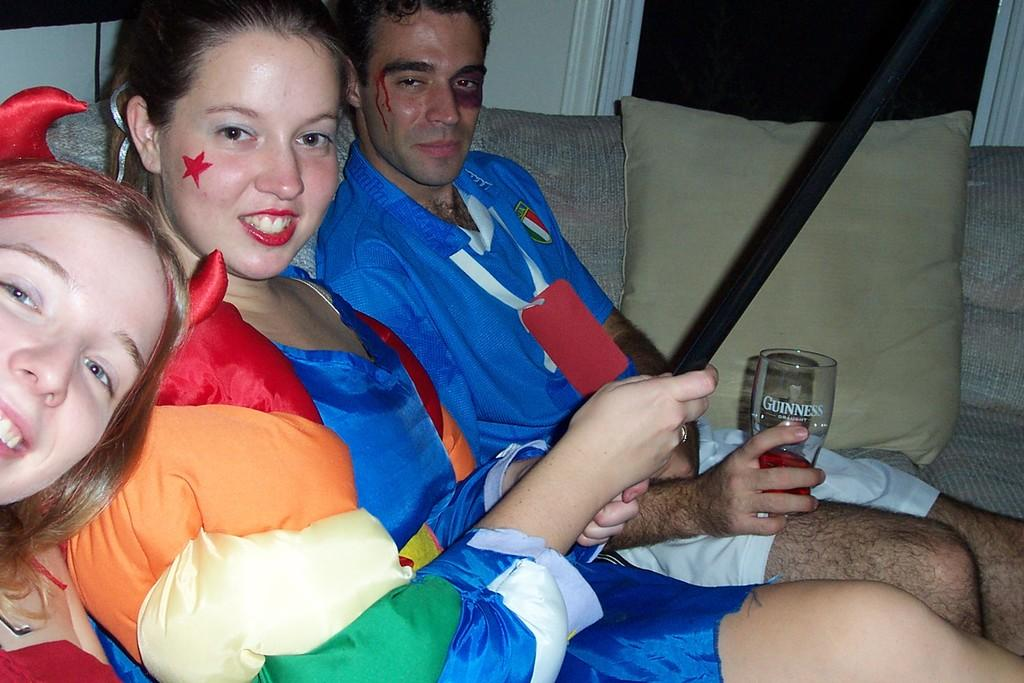<image>
Relay a brief, clear account of the picture shown. Some people sitting on a sofa, one holding a can of Guinness. 